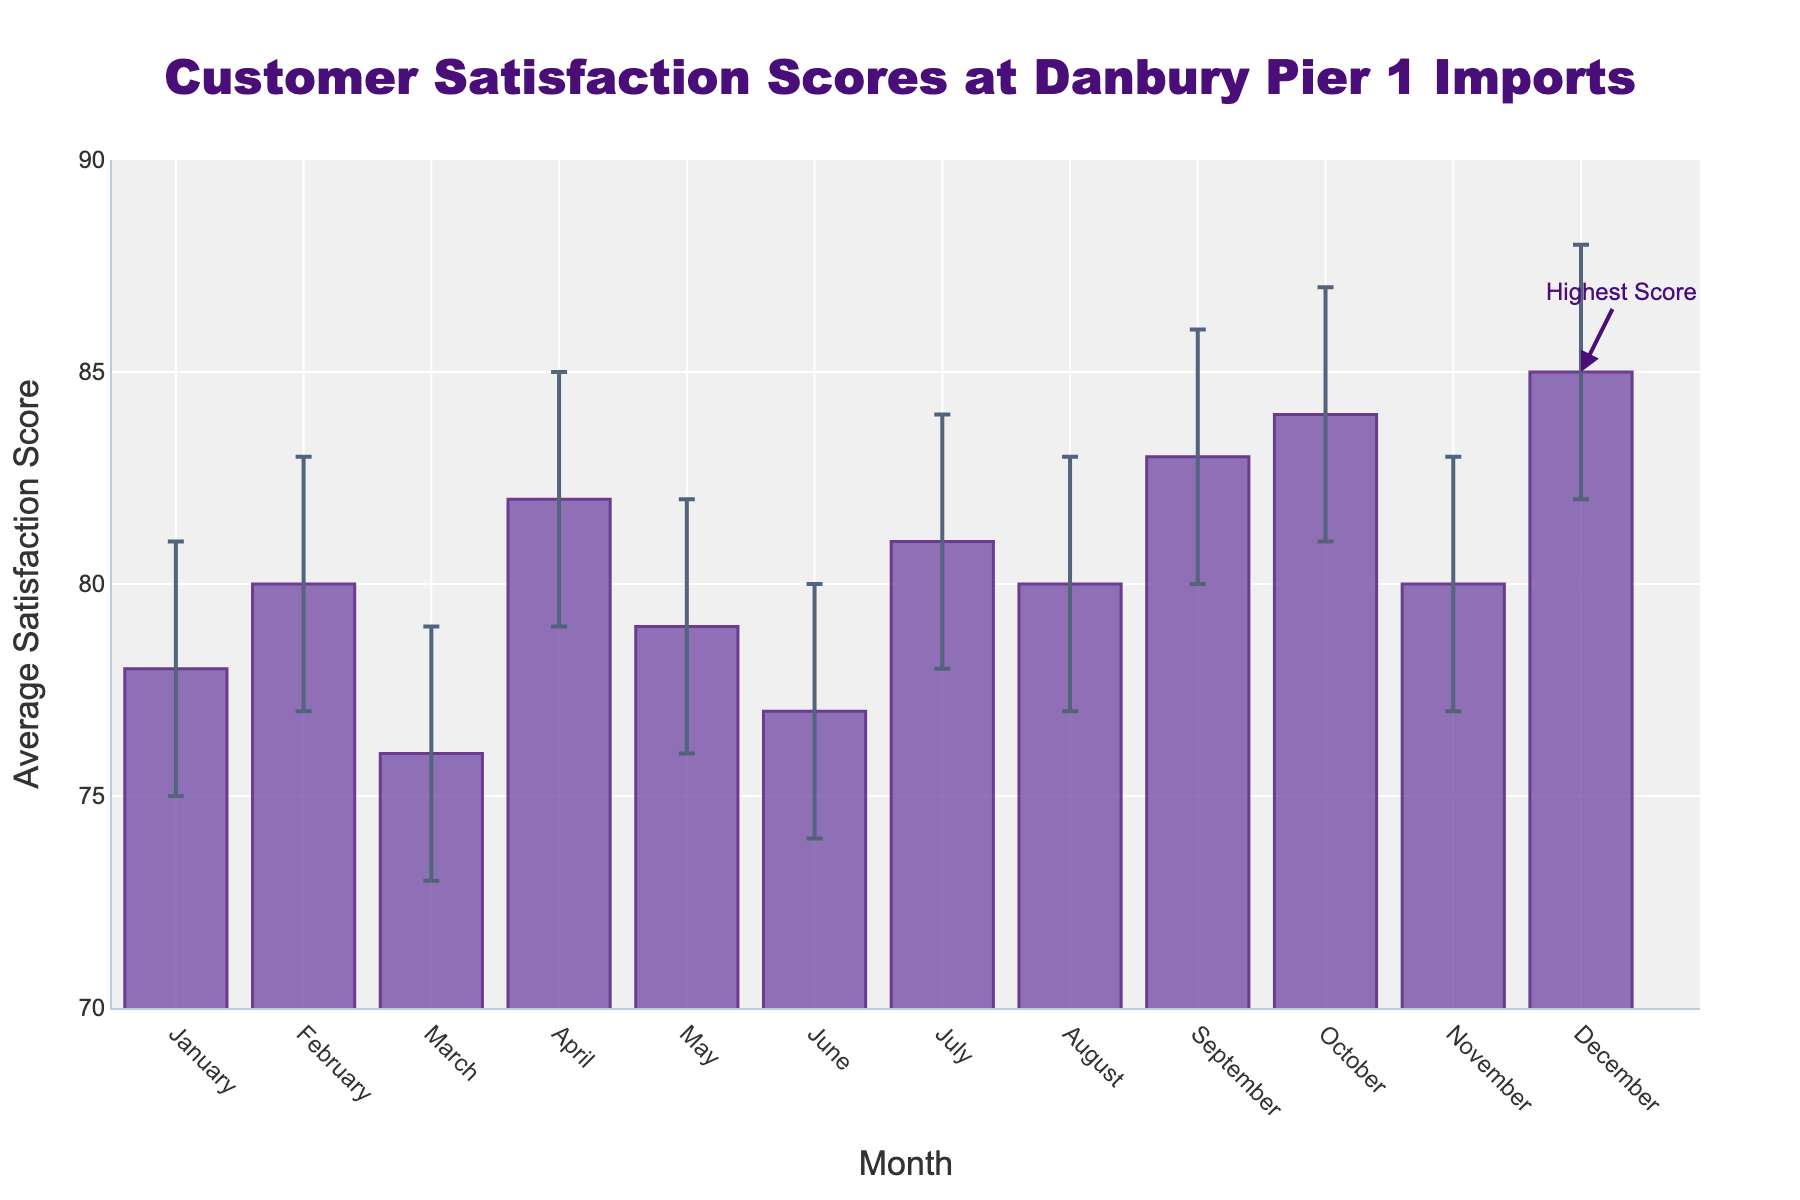What is the title of the figure? The title is usually displayed at the top of the figure. In this case, it says "Customer Satisfaction Scores at Danbury Pier 1 Imports".
Answer: Customer Satisfaction Scores at Danbury Pier 1 Imports What does the y-axis represent? The y-axis label specifies what is being measured, which in this figure is "Average Satisfaction Score".
Answer: Average Satisfaction Score In which month did the store achieve the highest average satisfaction score? Look at the heights of the bars and identify the month with the tallest bar, which in this case is "December" with a score of 85.
Answer: December What is the range of average satisfaction scores shown on the y-axis? The y-axis ranges from 70 to 90, as indicated by the axis labels.
Answer: 70 to 90 How many months reported an average satisfaction score of 80 or above? Count the bars with heights at or above the 80 mark on the y-axis. The months are February, April, July, August, September, October, November, and December, totaling 8 months.
Answer: 8 Which months have the lowest and highest satisfaction scores? To identify the lowest score, look for the shortest bar which is "March" with a score of 76. The highest score is in "December" with a score of 85.
Answer: March, December What is the difference in satisfaction scores between the highest and lowest-scoring months? Subtract the lowest score (March, 76) from the highest score (December, 85): 85 - 76.
Answer: 9 What does the annotation "Highest Score" point to? The annotation points to the bar representing "December", which has the highest average satisfaction score of 85.
Answer: December Which months have overlapping confidence intervals with February? February's confidence interval ranges from 77 to 83. The months with overlapping confidence intervals are January (75-81), May (76-82), June (74-80), July (78-84), August (77-83), and November (77-83).
Answer: January, May, June, July, August, November How can you tell which months have higher uncertainty in satisfaction scores than others? Uncertainty is represented by the length of the error bars. Compare the lengths of the error bars for each month and note that longer error bars indicate higher uncertainty. Months like July, August, and November have relatively longer error bars compared to others.
Answer: By comparing the error bar lengths 